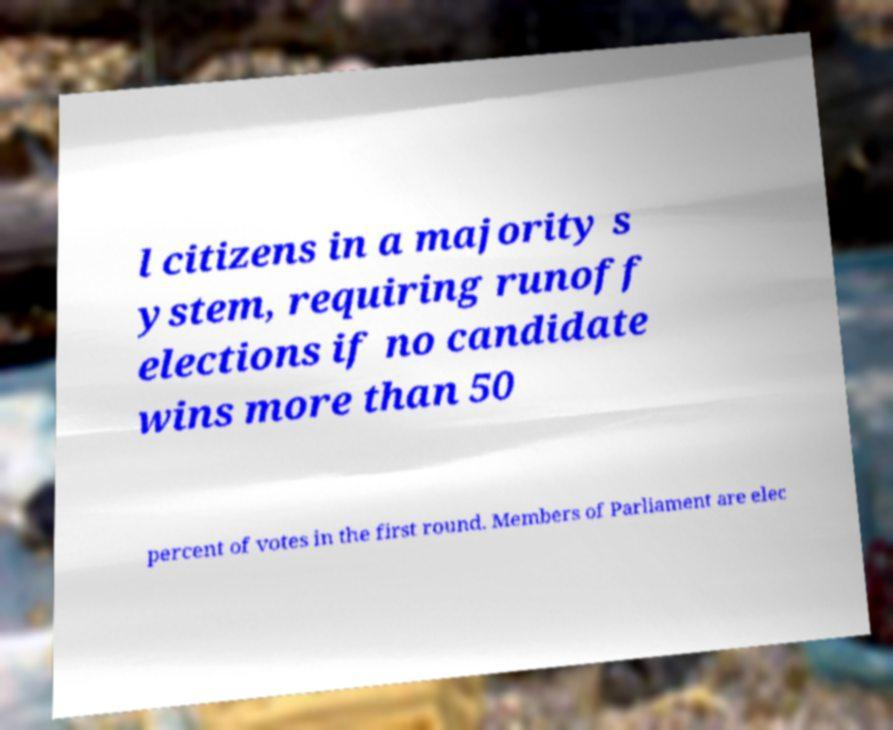Can you read and provide the text displayed in the image?This photo seems to have some interesting text. Can you extract and type it out for me? l citizens in a majority s ystem, requiring runoff elections if no candidate wins more than 50 percent of votes in the first round. Members of Parliament are elec 